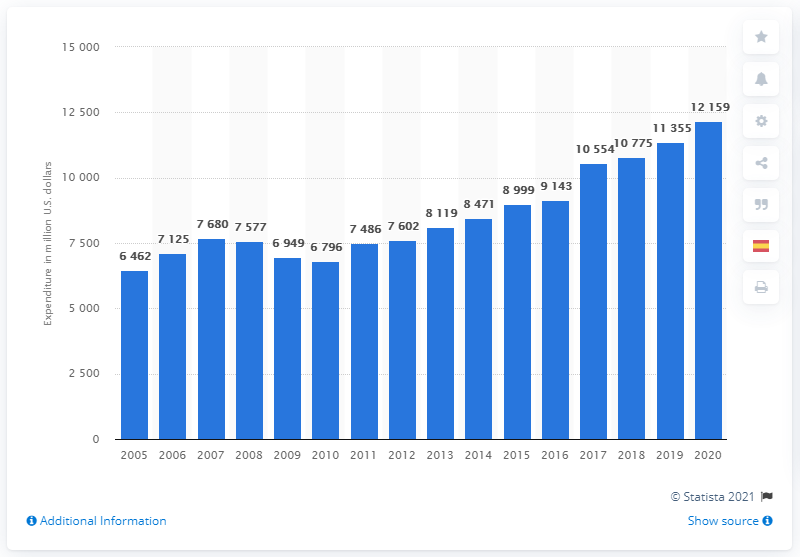List a handful of essential elements in this visual. Johnson & Johnson spent $12,159 on research and development programs in 2020. In 2010, Johnson & Johnson spent approximately 6,796 million dollars on research and development. 